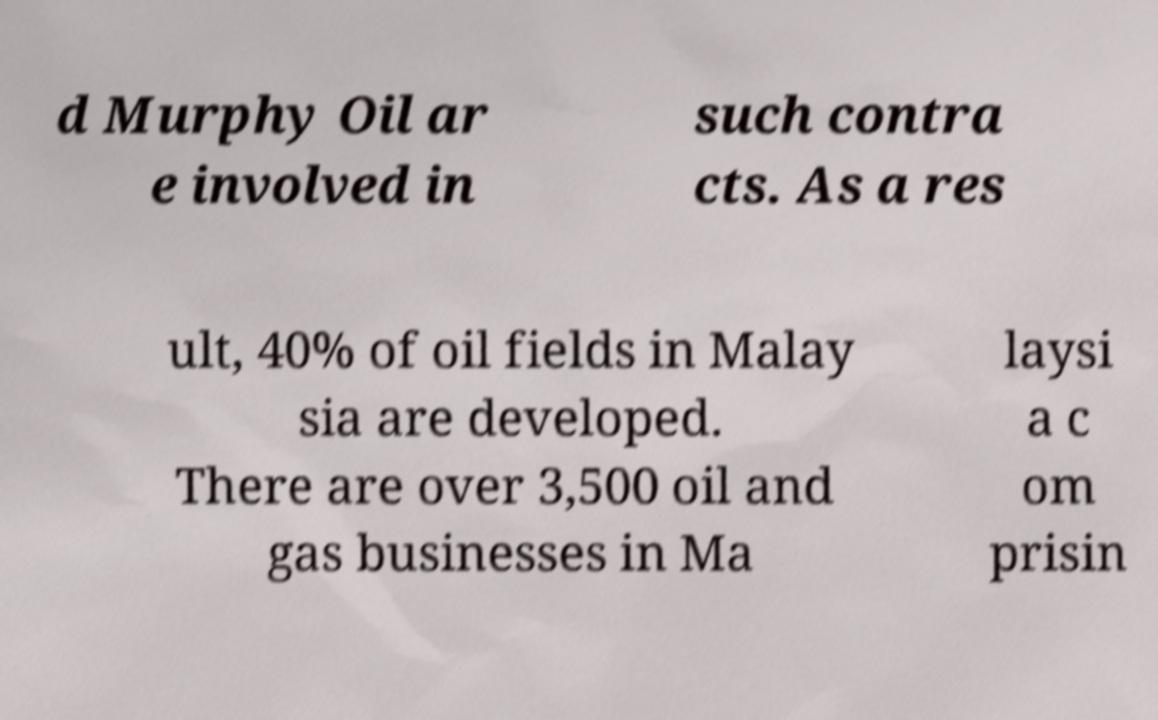I need the written content from this picture converted into text. Can you do that? d Murphy Oil ar e involved in such contra cts. As a res ult, 40% of oil fields in Malay sia are developed. There are over 3,500 oil and gas businesses in Ma laysi a c om prisin 